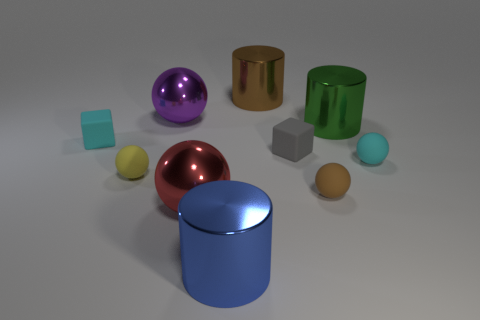Subtract all large spheres. How many spheres are left? 3 Subtract all yellow balls. How many balls are left? 4 Subtract 2 cylinders. How many cylinders are left? 1 Subtract all cubes. How many objects are left? 8 Add 4 large brown rubber things. How many large brown rubber things exist? 4 Subtract 0 green balls. How many objects are left? 10 Subtract all cyan spheres. Subtract all purple cubes. How many spheres are left? 4 Subtract all small red metallic blocks. Subtract all tiny yellow balls. How many objects are left? 9 Add 1 cyan cubes. How many cyan cubes are left? 2 